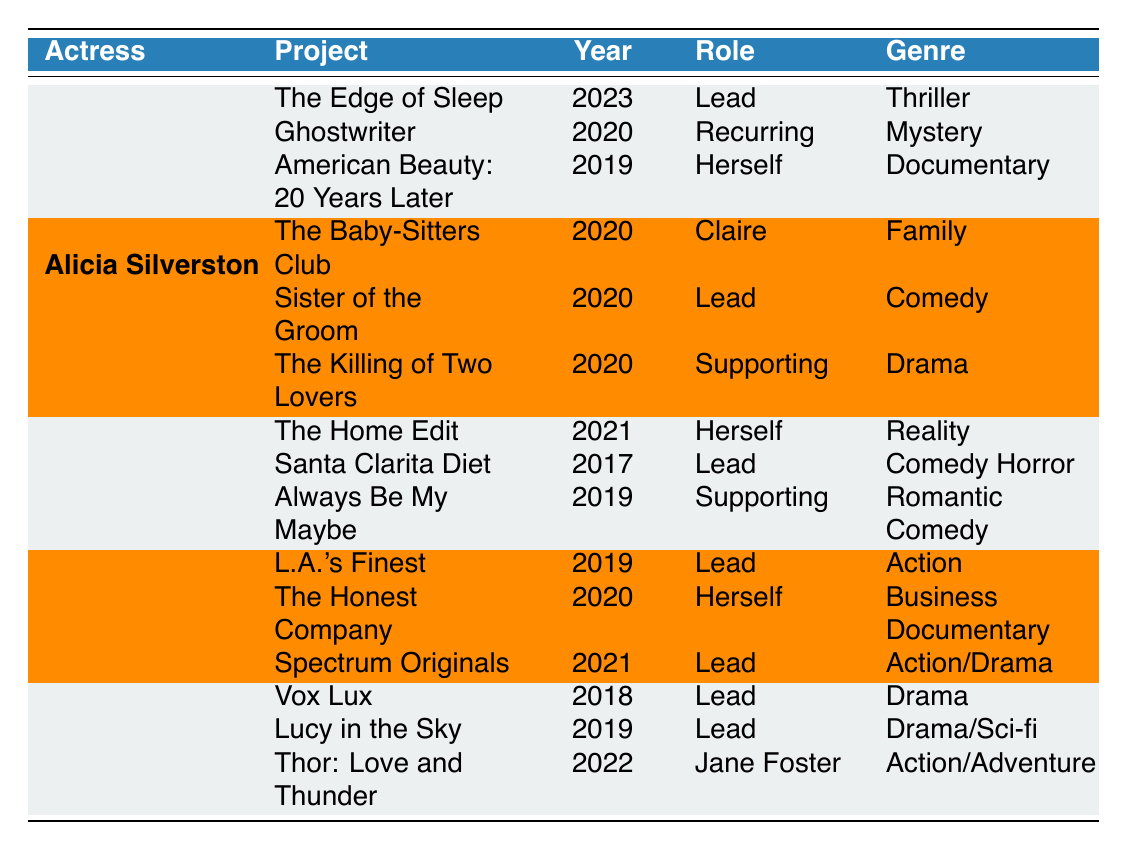What is the title of Thora Birch's most recent project? Thora Birch's most recent project listed in the table is "The Edge of Sleep," which was released in 2023. This can be found by looking at the last entry in her row, where the year is also noted.
Answer: The Edge of Sleep How many projects has Jessica Alba worked on since 2019? Jessica Alba has three recent projects listed in the table, all of which are from the years 2019 to 2021. They are "L.A.'s Finest" (2019), "The Honest Company" (2020), and "Spectrum Originals" (2021), making the total count of her projects since 2019 three.
Answer: 3 Did Natalie Portman have any projects in 2020? Looking at Natalie Portman's row, none of her listed projects fall under the year 2020. The mentioned projects are from 2018, 2019, and 2022. Therefore, the answer is that she did not have any projects in 2020.
Answer: No Which actress has the highest variety in genre among their recent projects? To determine this, we can look at the genres listed for each actress. Thora Birch shows diversity with thriller, mystery, and documentary; Alicia Silverstone has family, comedy, and drama; Drew Barrymore has reality, comedy horror, and romantic comedy; Jessica Alba features action, business documentary, and action/drama; Natalie Portman has drama, drama/sci-fi, and action/adventure. Both Thora Birch and Drew Barrymore display three different genres, so we compare them, and Drew Barrymore's genres are more uniquely distinct, indicating higher variety.
Answer: Drew Barrymore What is the total number of recent projects listed for all actresses combined? By counting all the projects across the actresses listed in the table: Thora Birch (3), Alicia Silverstone (3), Drew Barrymore (3), Jessica Alba (3), and Natalie Portman (3) results in a total of 15. This sum means we add 3+3 for each actress to reach the total.
Answer: 15 